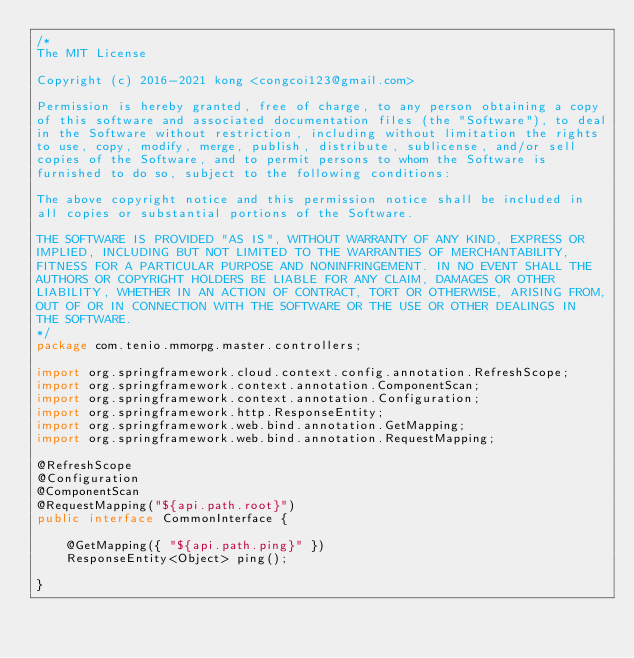Convert code to text. <code><loc_0><loc_0><loc_500><loc_500><_Java_>/*
The MIT License

Copyright (c) 2016-2021 kong <congcoi123@gmail.com>

Permission is hereby granted, free of charge, to any person obtaining a copy
of this software and associated documentation files (the "Software"), to deal
in the Software without restriction, including without limitation the rights
to use, copy, modify, merge, publish, distribute, sublicense, and/or sell
copies of the Software, and to permit persons to whom the Software is
furnished to do so, subject to the following conditions:

The above copyright notice and this permission notice shall be included in
all copies or substantial portions of the Software.

THE SOFTWARE IS PROVIDED "AS IS", WITHOUT WARRANTY OF ANY KIND, EXPRESS OR
IMPLIED, INCLUDING BUT NOT LIMITED TO THE WARRANTIES OF MERCHANTABILITY,
FITNESS FOR A PARTICULAR PURPOSE AND NONINFRINGEMENT. IN NO EVENT SHALL THE
AUTHORS OR COPYRIGHT HOLDERS BE LIABLE FOR ANY CLAIM, DAMAGES OR OTHER
LIABILITY, WHETHER IN AN ACTION OF CONTRACT, TORT OR OTHERWISE, ARISING FROM,
OUT OF OR IN CONNECTION WITH THE SOFTWARE OR THE USE OR OTHER DEALINGS IN
THE SOFTWARE.
*/
package com.tenio.mmorpg.master.controllers;

import org.springframework.cloud.context.config.annotation.RefreshScope;
import org.springframework.context.annotation.ComponentScan;
import org.springframework.context.annotation.Configuration;
import org.springframework.http.ResponseEntity;
import org.springframework.web.bind.annotation.GetMapping;
import org.springframework.web.bind.annotation.RequestMapping;

@RefreshScope
@Configuration
@ComponentScan
@RequestMapping("${api.path.root}")
public interface CommonInterface {

	@GetMapping({ "${api.path.ping}" })
	ResponseEntity<Object> ping();

}
</code> 